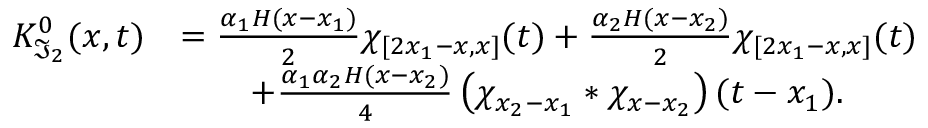<formula> <loc_0><loc_0><loc_500><loc_500>\begin{array} { r l } { K _ { \mathfrak { I } _ { 2 } } ^ { 0 } ( x , t ) } & { = \frac { \alpha _ { 1 } H ( x - x _ { 1 } ) } { 2 } \chi _ { [ 2 x _ { 1 } - x , x ] } ( t ) + \frac { \alpha _ { 2 } H ( x - x _ { 2 } ) } { 2 } \chi _ { [ 2 x _ { 1 } - x , x ] } ( t ) } \\ & { \quad + \frac { \alpha _ { 1 } \alpha _ { 2 } H ( x - x _ { 2 } ) } { 4 } \left ( \chi _ { x _ { 2 } - x _ { 1 } } \ast \chi _ { x - x _ { 2 } } \right ) ( t - x _ { 1 } ) . } \end{array}</formula> 